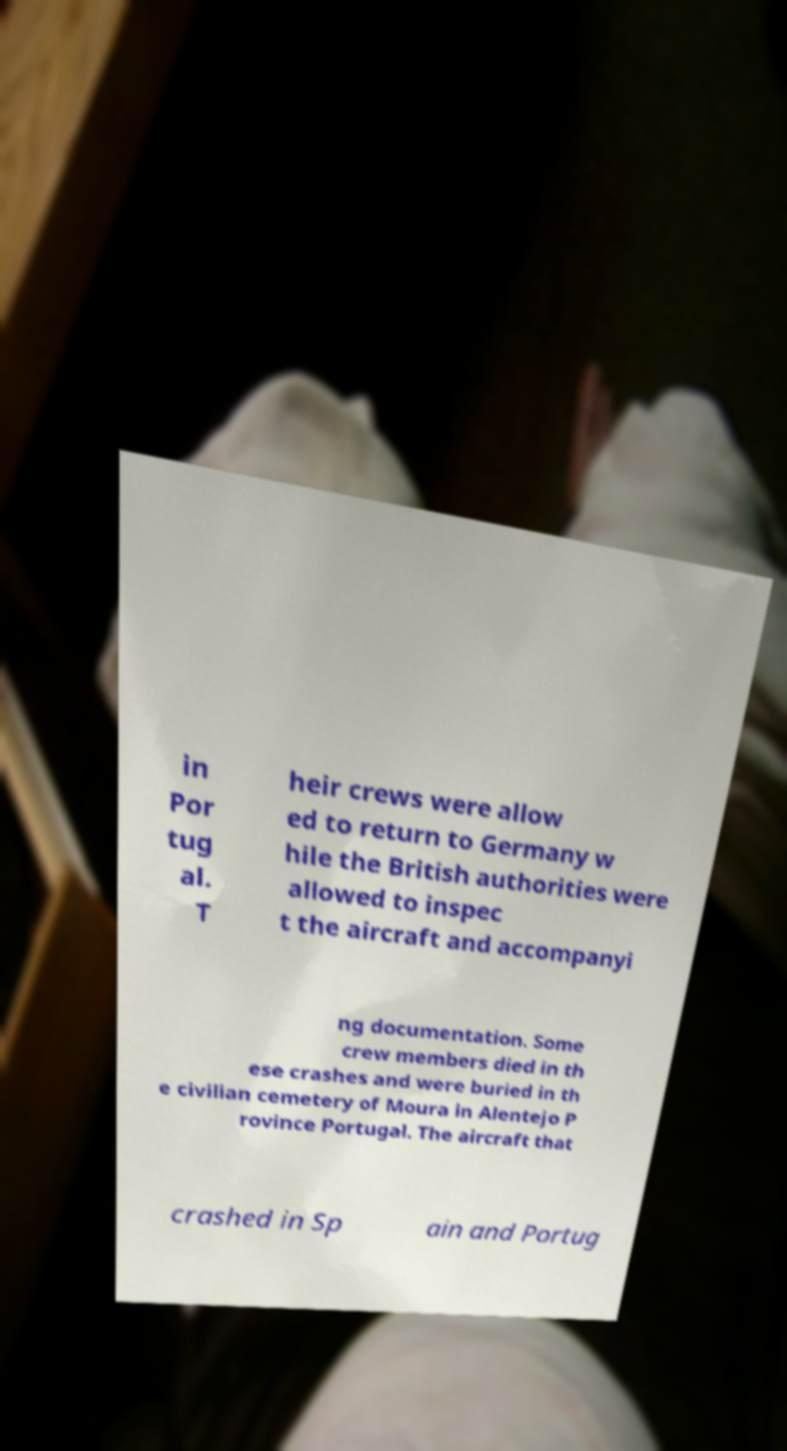Please read and relay the text visible in this image. What does it say? in Por tug al. T heir crews were allow ed to return to Germany w hile the British authorities were allowed to inspec t the aircraft and accompanyi ng documentation. Some crew members died in th ese crashes and were buried in th e civilian cemetery of Moura in Alentejo P rovince Portugal. The aircraft that crashed in Sp ain and Portug 